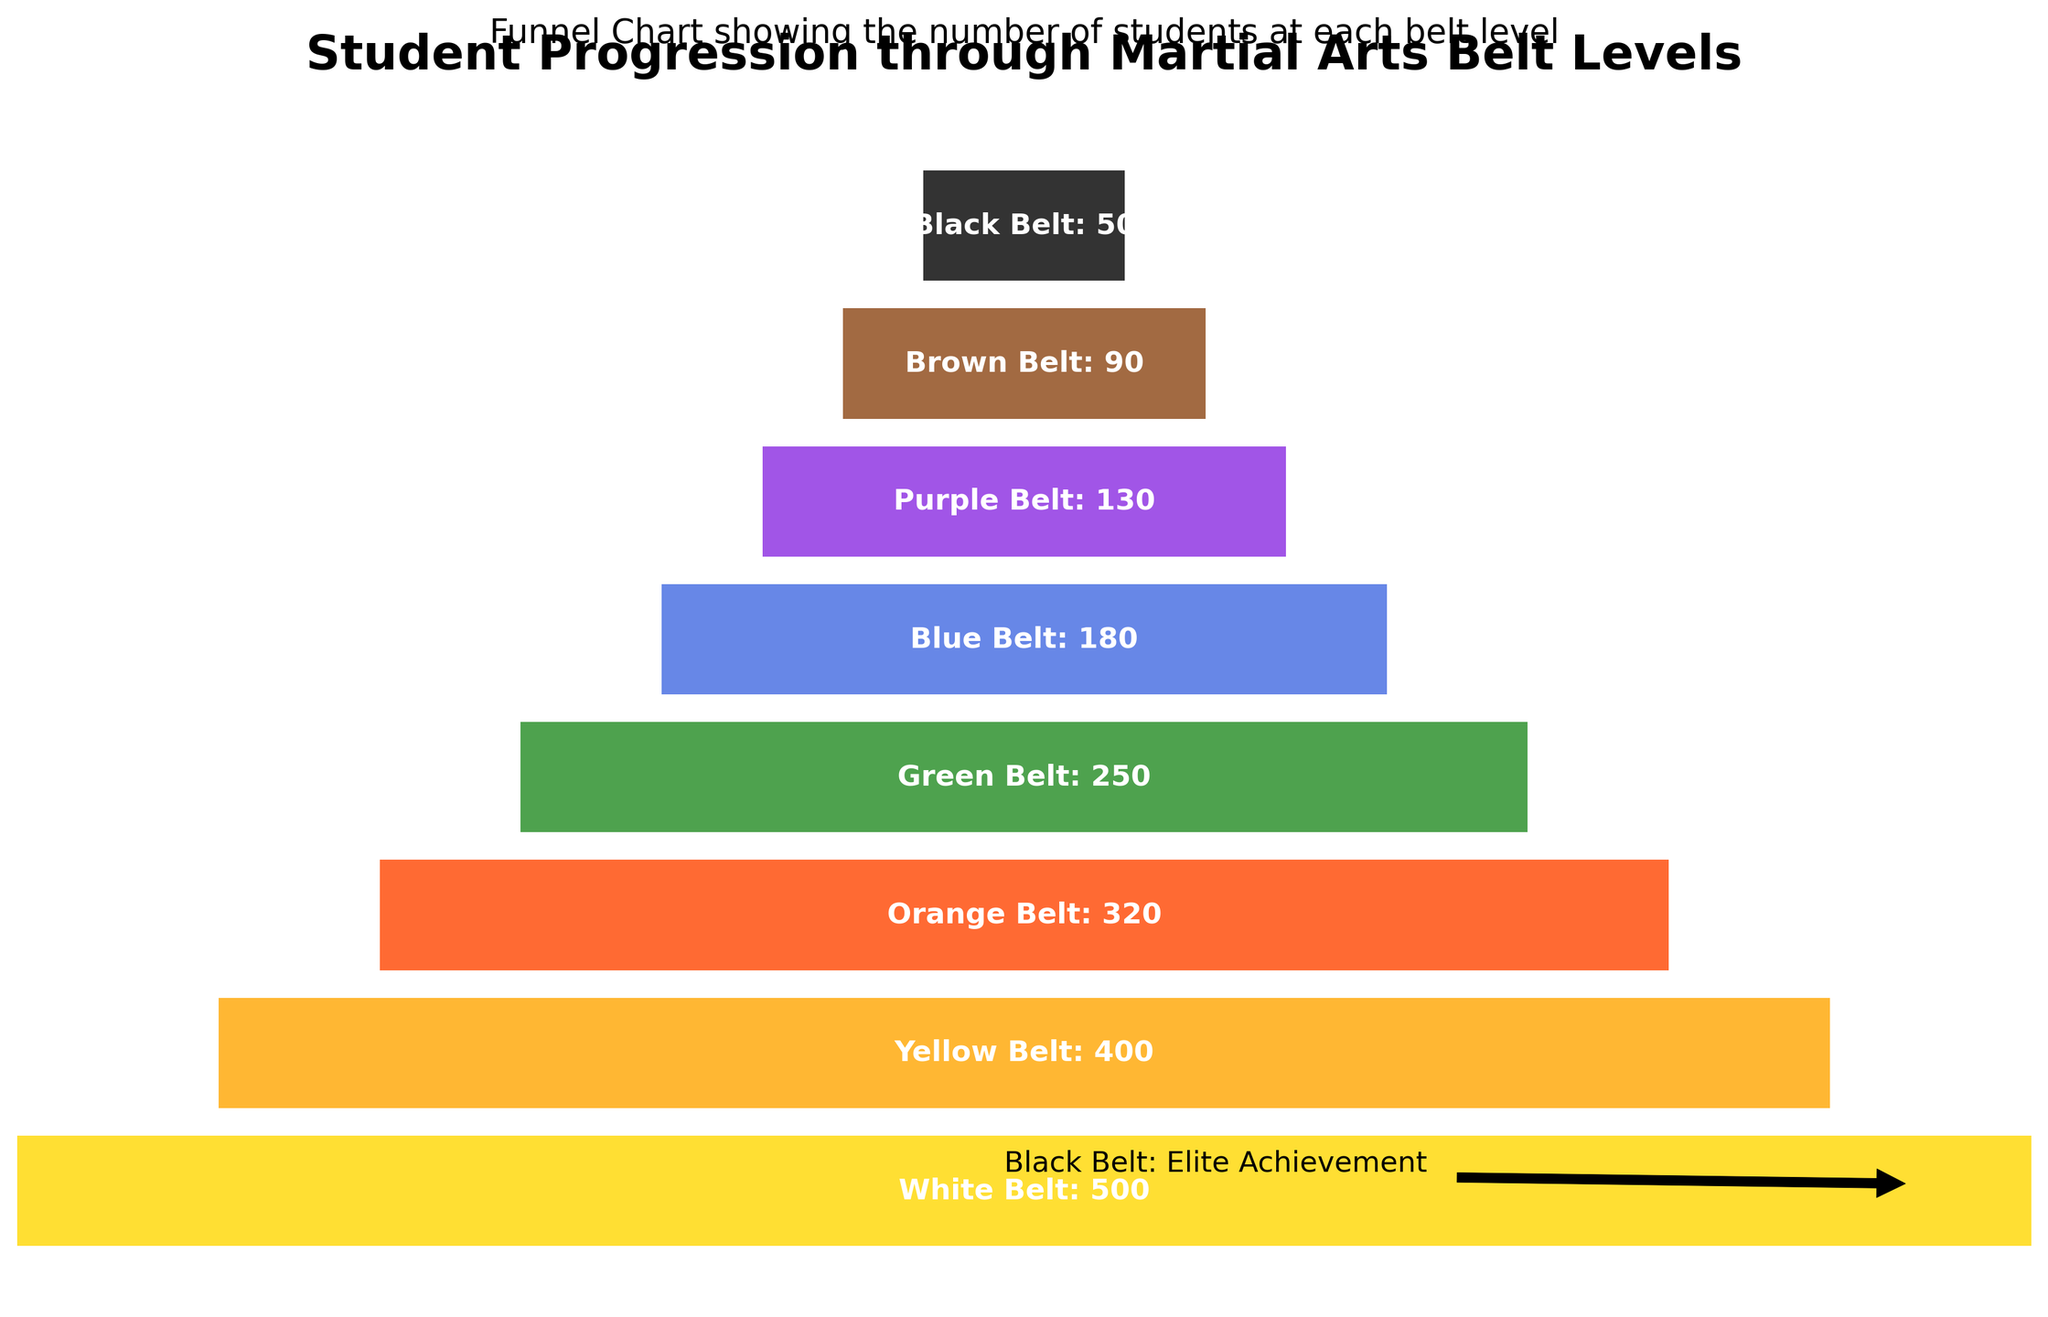How many students are at the White Belt level? Look at the funnel chart and find the label "White Belt." The number next to it indicates there are 500 students at this level.
Answer: 500 At which belt level do we see the most significant drop in student numbers? Identify where the student numbers decrease the most between adjacent belt levels. The biggest drop is between Green Belt (250) and Blue Belt (180), resulting in a decrease of 70 students.
Answer: Green Belt to Blue Belt Which belt level has half the number of students compared to the White Belt level? Refer to the White Belt level, which has 500 students. Half of this number is 250. Check which belt level has approximately 250 students, which is the Green Belt level.
Answer: Green Belt What are the colors used for the belts in the funnel chart? Examine the color segments for each belt level in the chart: gold for White Belt, orange for Yellow Belt, red-orange for Orange Belt, green for Green Belt, blue for Blue Belt, purple for Purple Belt, brown for Brown Belt, and black for Black Belt.
Answer: Gold, orange, red-orange, green, blue, purple, brown, black How many belt levels have student numbers under 100? Check the chart for belt levels with student numbers under 100: Brown Belt (90) and Black Belt (50). Therefore, there are 2 such levels.
Answer: 2 What is the student retention rate from White Belt to Yellow Belt? Calculate the retention rate by dividing the number of Yellow Belt students (400) by the number of White Belt students (500), then multiply by 100 to get the percentage: (400/500)*100 = 80%.
Answer: 80% What proportion of students have achieved Black Belt compared to the initial White Belt count? Divide the number of Black Belt students (50) by the number of White Belt students (500), then multiply by 100 to get the percentage: (50/500)*100 = 10%.
Answer: 10% Which belt level comes after Green Belt in terms of student number count? Examine the funnel chart and note the sequence. After Green Belt with 250 students, Blue Belt follows with 180 students.
Answer: Blue Belt How many students do we have in total across all belt levels? Sum the students across all levels: 500 (White) + 400 (Yellow) + 320 (Orange) + 250 (Green) + 180 (Blue) + 130 (Purple) + 90 (Brown) + 50 (Black) = 1920.
Answer: 1920 Is there any annotation in the chart, and what does it indicate? Yes, there is an annotation near the lower right of the chart, pointing out that the Black Belt represents an elite achievement.
Answer: Black Belt: Elite Achievement 